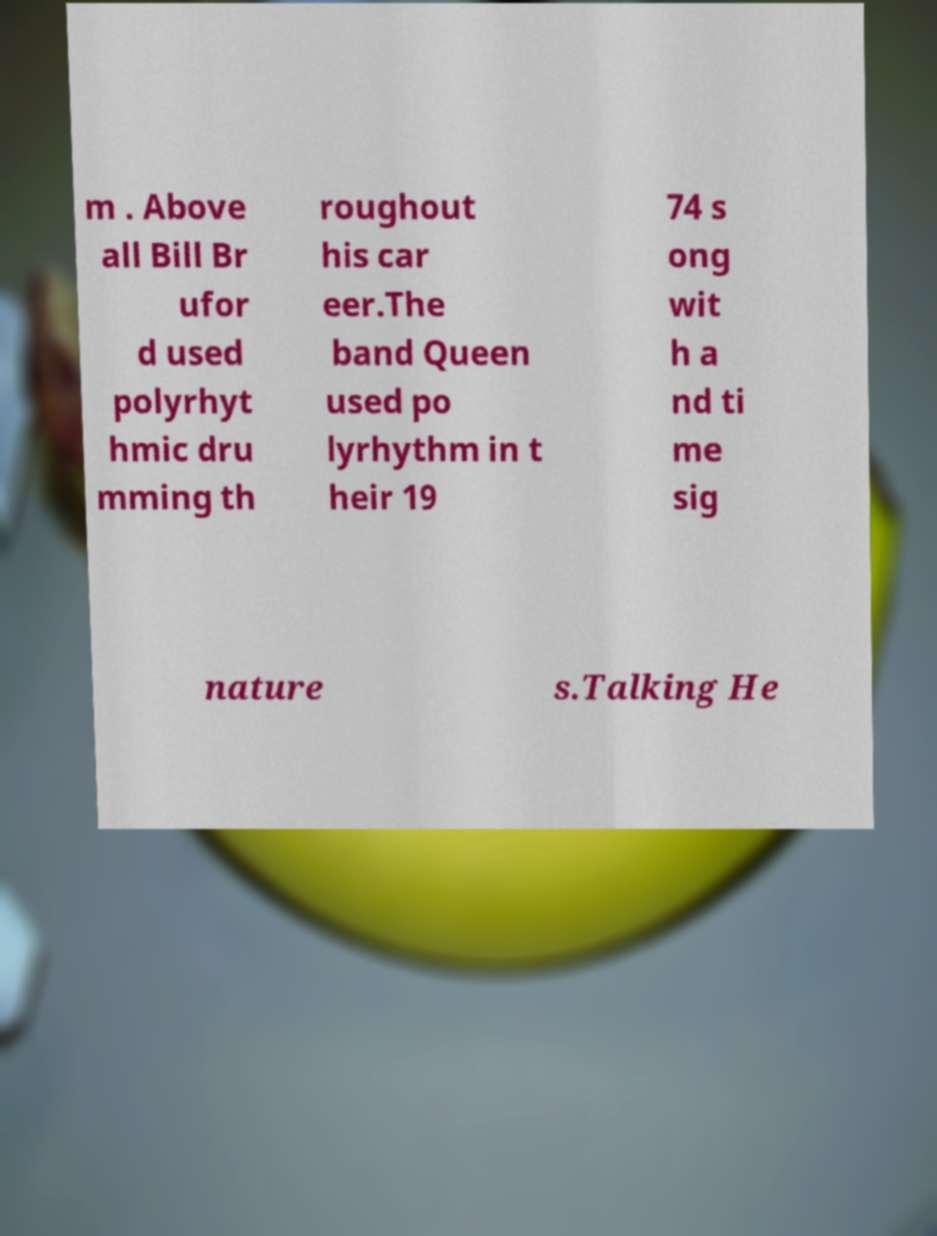Could you extract and type out the text from this image? m . Above all Bill Br ufor d used polyrhyt hmic dru mming th roughout his car eer.The band Queen used po lyrhythm in t heir 19 74 s ong wit h a nd ti me sig nature s.Talking He 